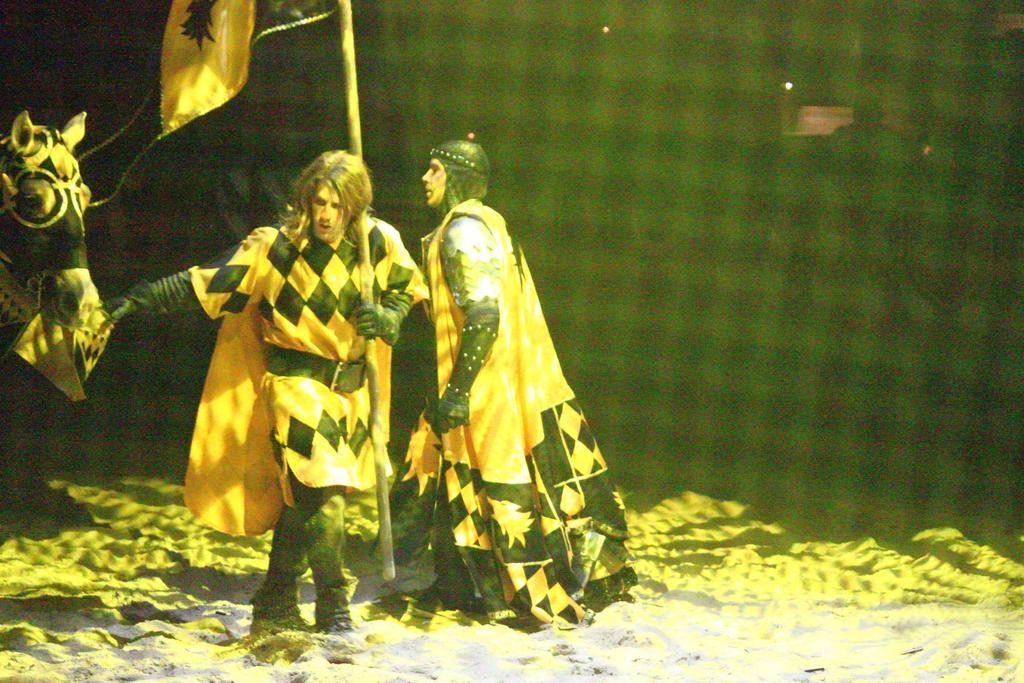How would you summarize this image in a sentence or two? In this image there are two people standing. They are wearing costumes. The man standing on the left is holding a flag and we can see a horse. At the bottom there is sand. In the background there are lights. 